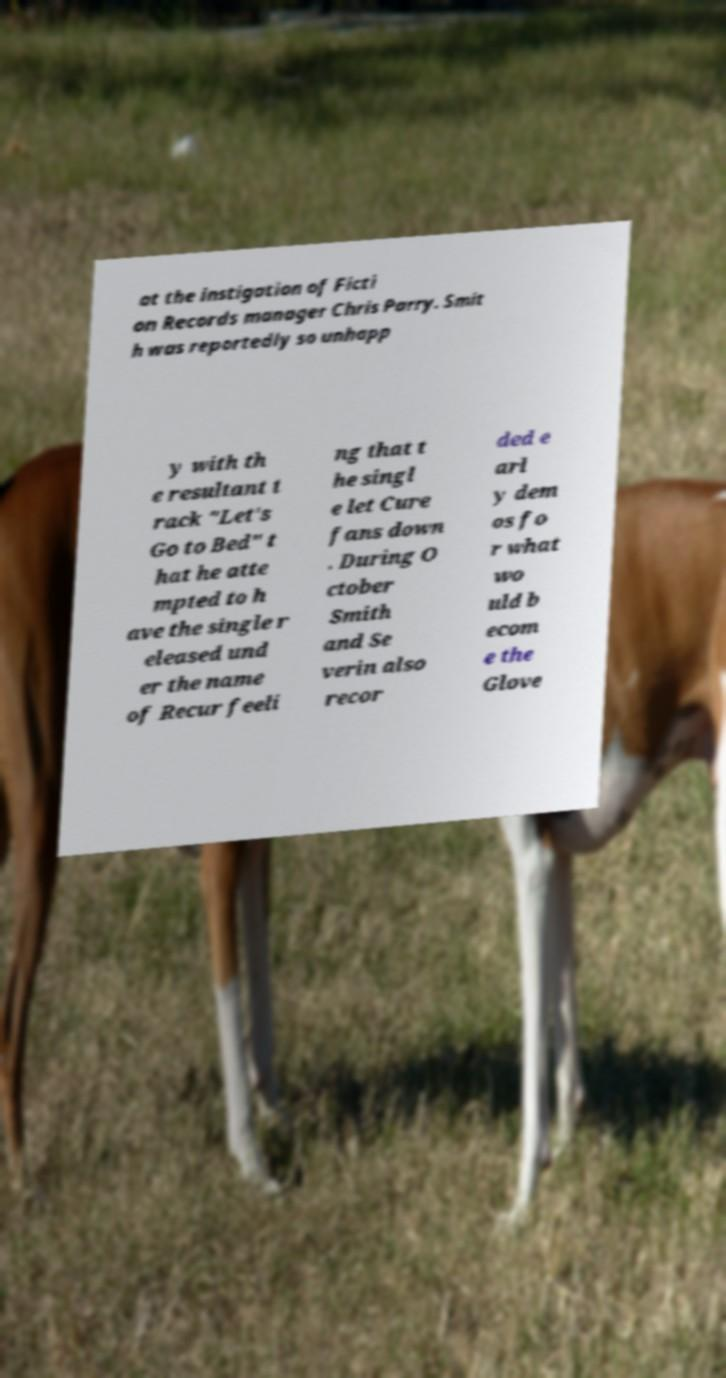For documentation purposes, I need the text within this image transcribed. Could you provide that? at the instigation of Ficti on Records manager Chris Parry. Smit h was reportedly so unhapp y with th e resultant t rack "Let's Go to Bed" t hat he atte mpted to h ave the single r eleased und er the name of Recur feeli ng that t he singl e let Cure fans down . During O ctober Smith and Se verin also recor ded e arl y dem os fo r what wo uld b ecom e the Glove 